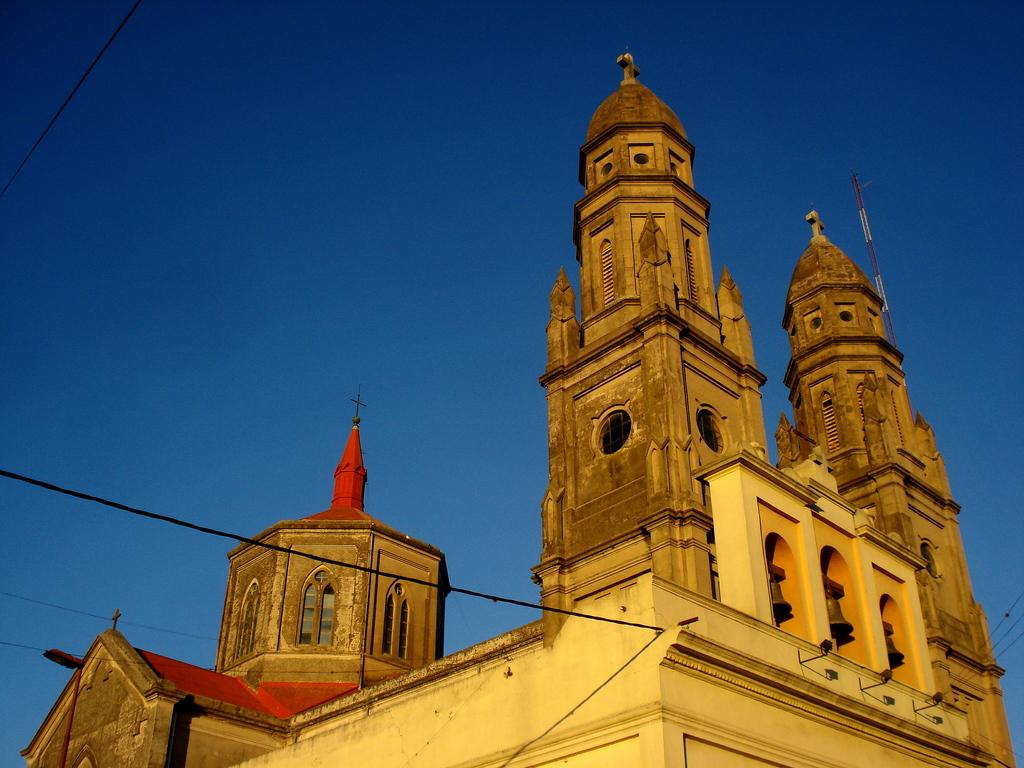What type of building is in the image? There is a church building in the image. Where is the church building located in the image? The church building is in the background. What else can be seen in the image besides the church building? The sky is visible in the image. What type of pump is visible in the image? There is no pump present in the image. 